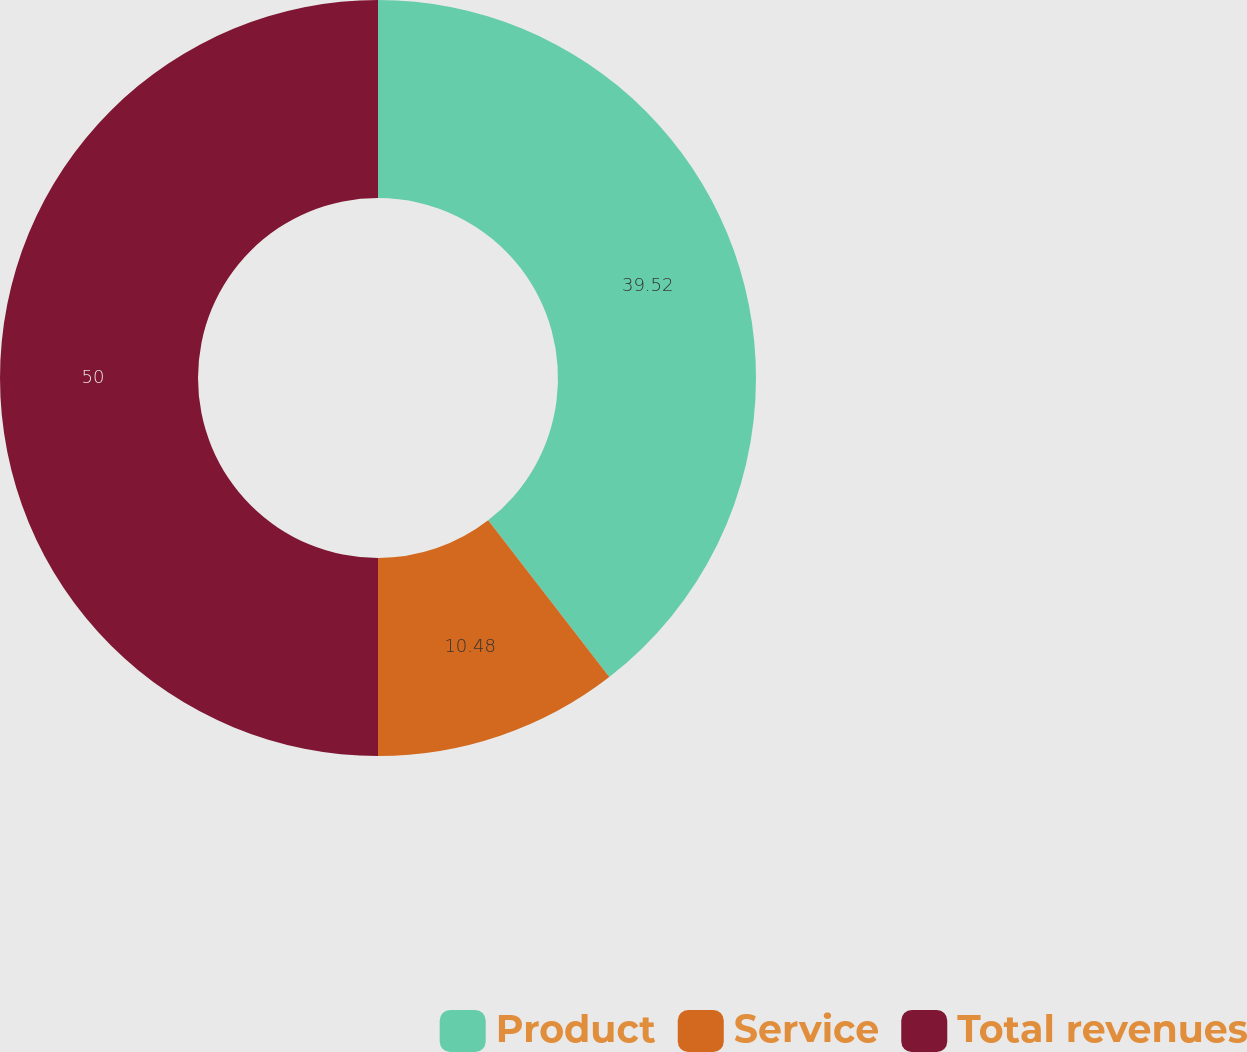<chart> <loc_0><loc_0><loc_500><loc_500><pie_chart><fcel>Product<fcel>Service<fcel>Total revenues<nl><fcel>39.52%<fcel>10.48%<fcel>50.0%<nl></chart> 